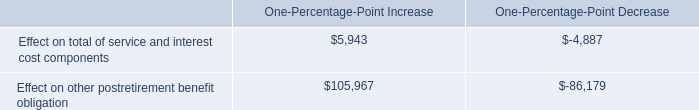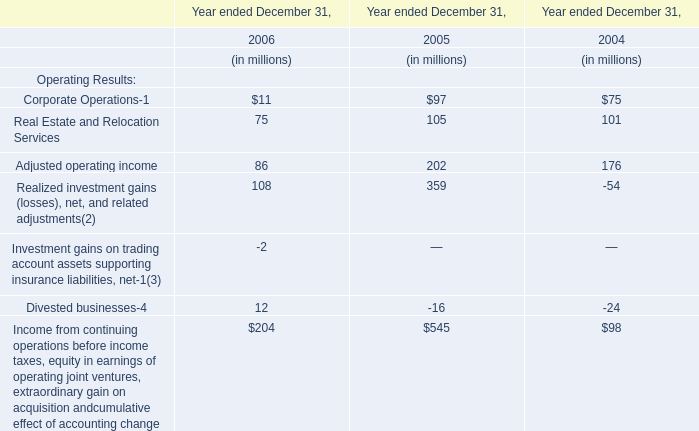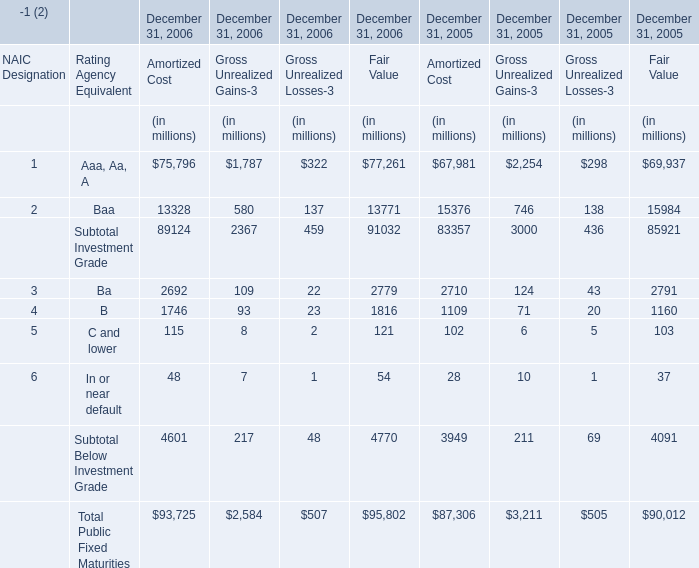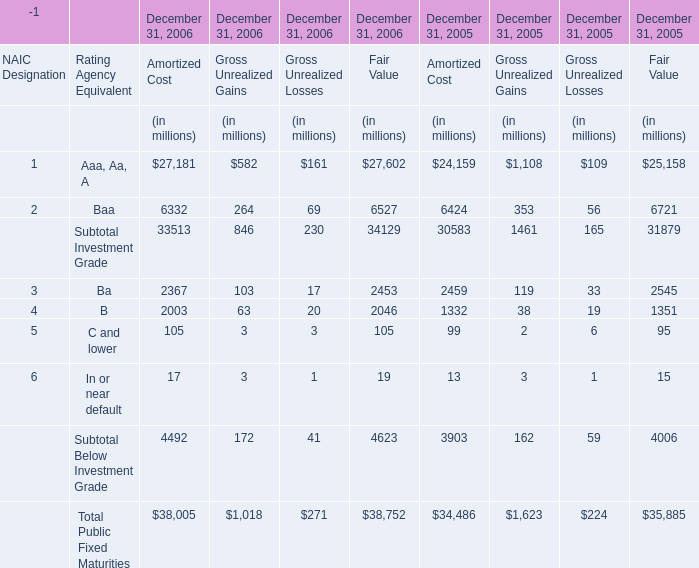What is the proportion of all Amortized Cost that are greater than10000 to the total amount of Amortized Cost, in 2006 for December 31, 2006? 
Computations: ((75796 + 13328) / (89124 + 4601))
Answer: 0.95091. 